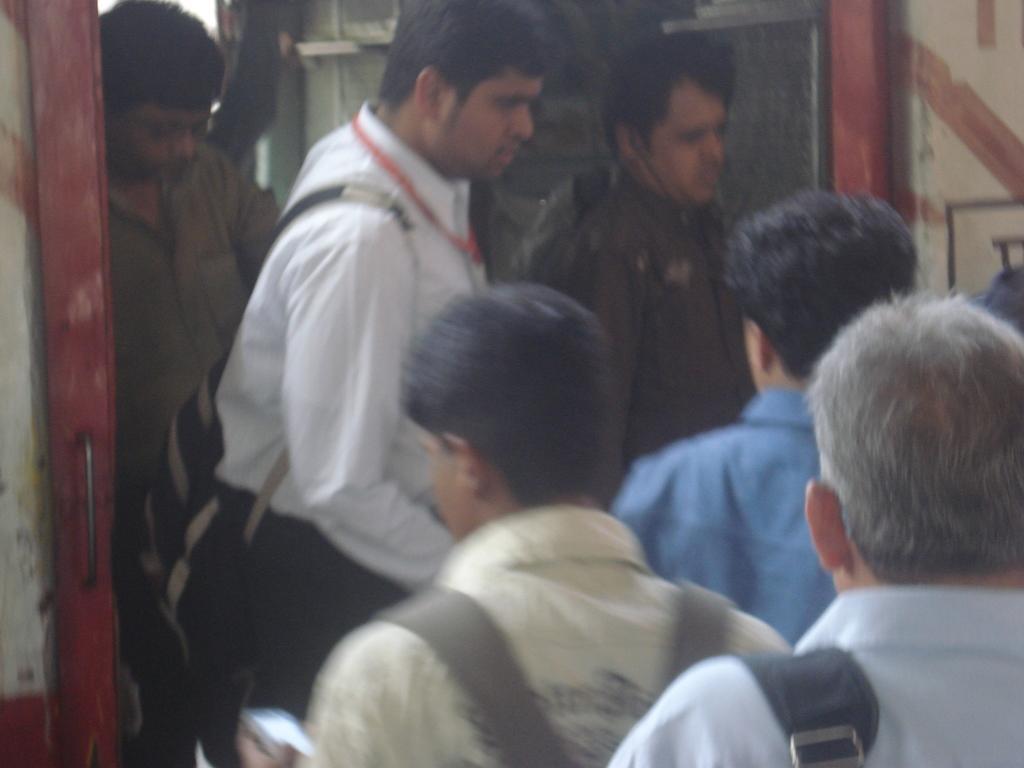Please provide a concise description of this image. In this image there are group of persons standing and walking. 